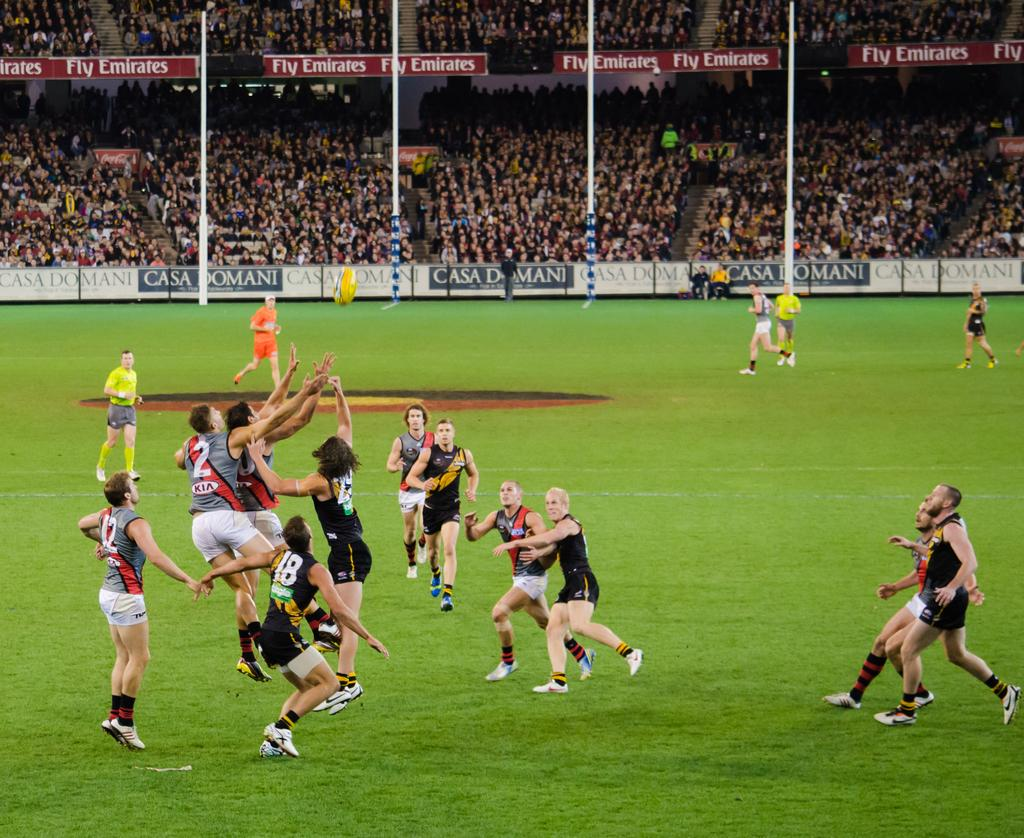<image>
Relay a brief, clear account of the picture shown. Players participate in an Australian rules football game in front of thousands of spectators surrounded by Fly Emirates advertising 